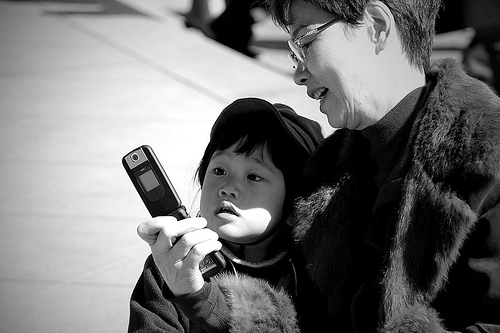How many people are there? 2 